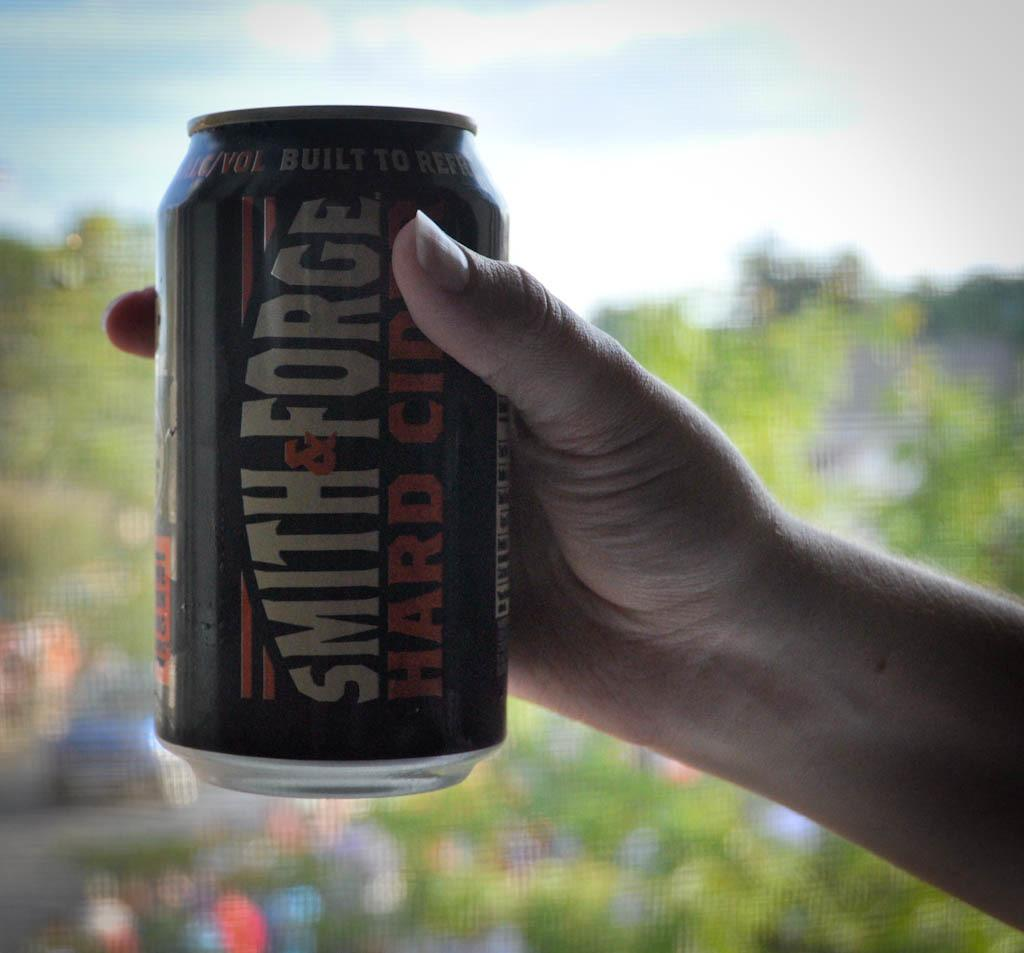Provide a one-sentence caption for the provided image. a can that has the name Smith on it. 